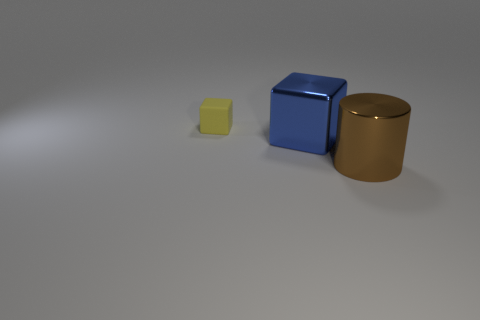Add 2 shiny cylinders. How many objects exist? 5 Subtract all blocks. How many objects are left? 1 Subtract 0 yellow balls. How many objects are left? 3 Subtract all big brown shiny cylinders. Subtract all blue objects. How many objects are left? 1 Add 3 big brown metal objects. How many big brown metal objects are left? 4 Add 3 big cylinders. How many big cylinders exist? 4 